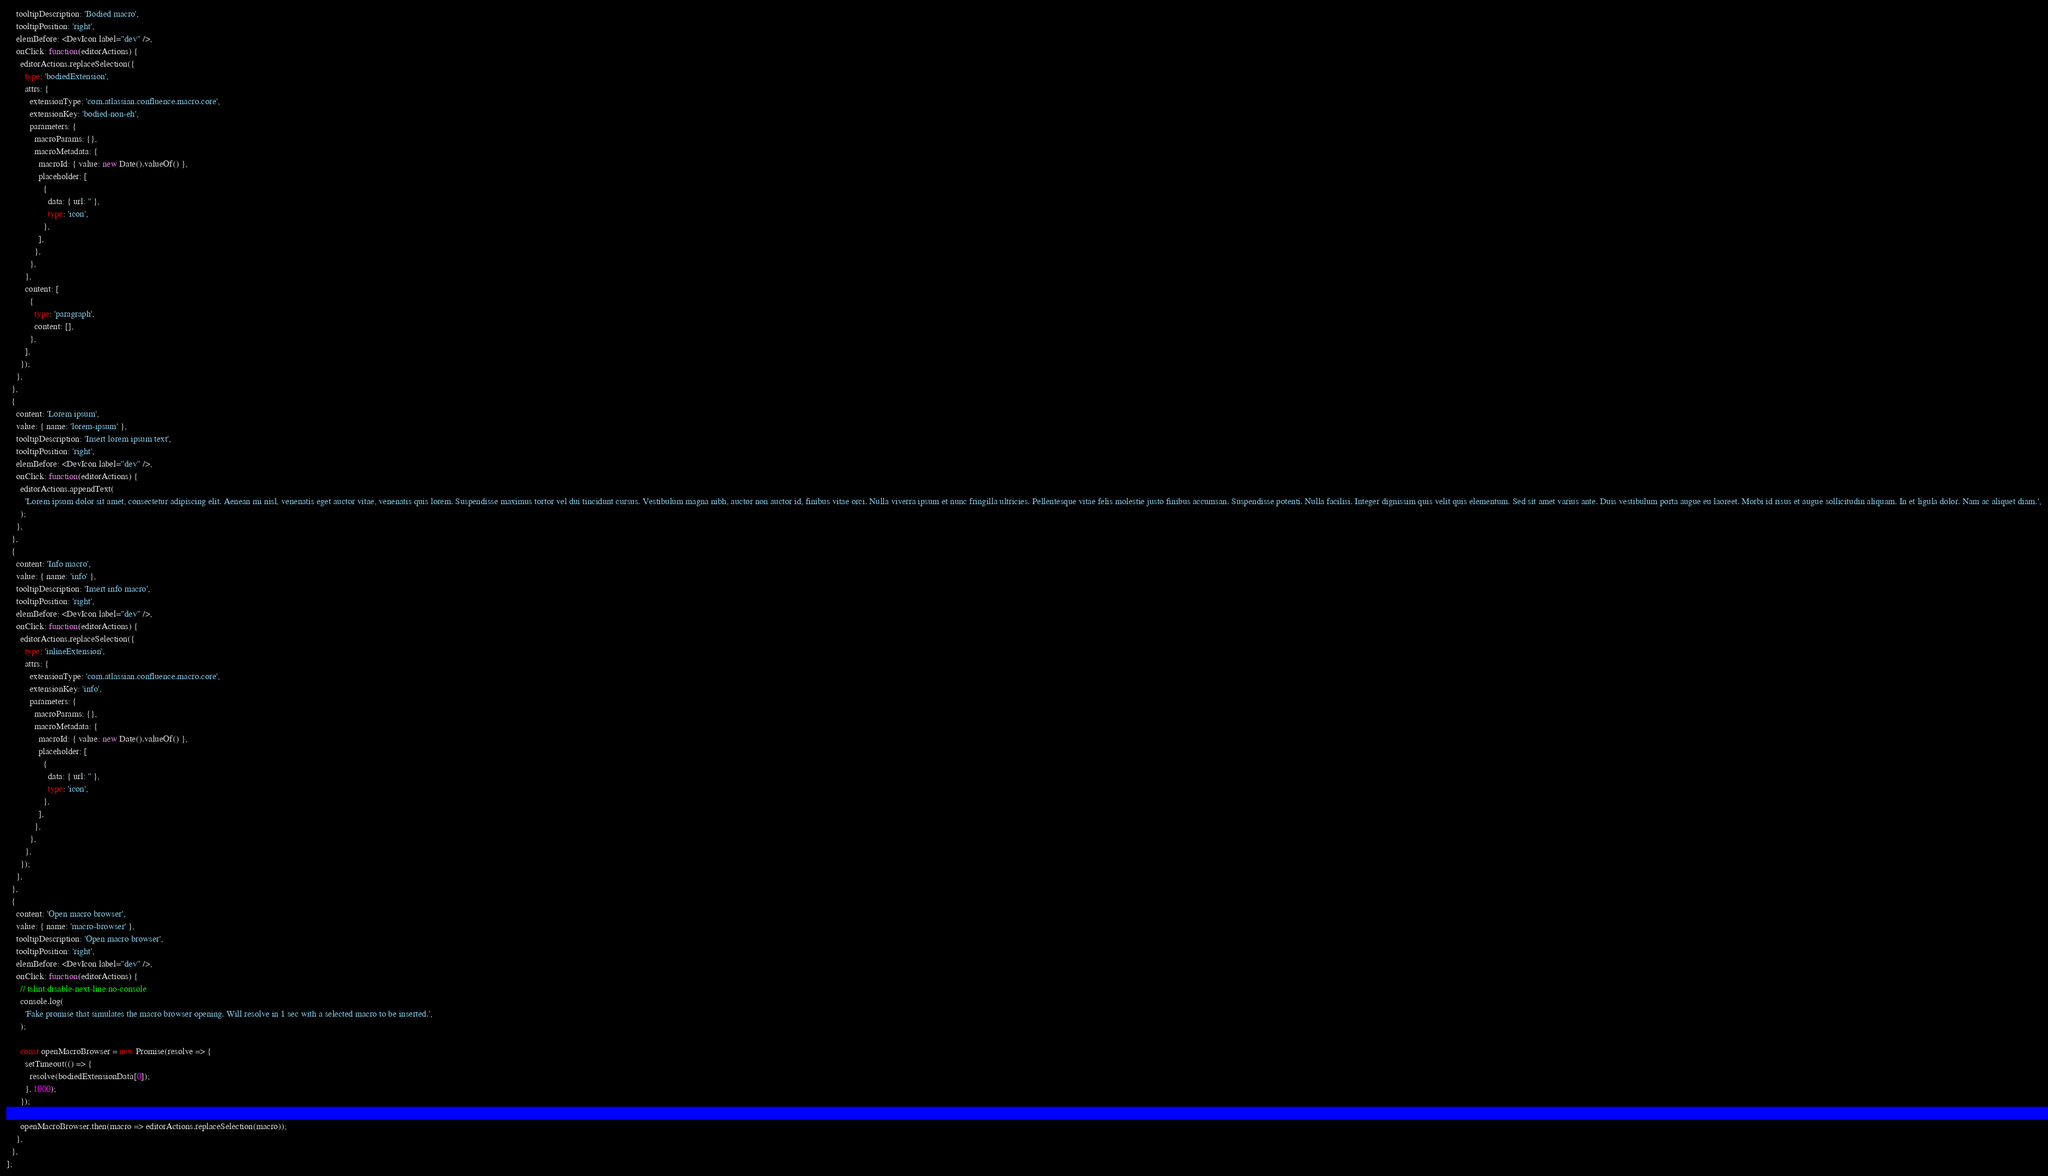<code> <loc_0><loc_0><loc_500><loc_500><_TypeScript_>    tooltipDescription: 'Bodied macro',
    tooltipPosition: 'right',
    elemBefore: <DevIcon label="dev" />,
    onClick: function(editorActions) {
      editorActions.replaceSelection({
        type: 'bodiedExtension',
        attrs: {
          extensionType: 'com.atlassian.confluence.macro.core',
          extensionKey: 'bodied-non-eh',
          parameters: {
            macroParams: {},
            macroMetadata: {
              macroId: { value: new Date().valueOf() },
              placeholder: [
                {
                  data: { url: '' },
                  type: 'icon',
                },
              ],
            },
          },
        },
        content: [
          {
            type: 'paragraph',
            content: [],
          },
        ],
      });
    },
  },
  {
    content: 'Lorem ipsum',
    value: { name: 'lorem-ipsum' },
    tooltipDescription: 'Insert lorem ipsum text',
    tooltipPosition: 'right',
    elemBefore: <DevIcon label="dev" />,
    onClick: function(editorActions) {
      editorActions.appendText(
        'Lorem ipsum dolor sit amet, consectetur adipiscing elit. Aenean mi nisl, venenatis eget auctor vitae, venenatis quis lorem. Suspendisse maximus tortor vel dui tincidunt cursus. Vestibulum magna nibh, auctor non auctor id, finibus vitae orci. Nulla viverra ipsum et nunc fringilla ultricies. Pellentesque vitae felis molestie justo finibus accumsan. Suspendisse potenti. Nulla facilisi. Integer dignissim quis velit quis elementum. Sed sit amet varius ante. Duis vestibulum porta augue eu laoreet. Morbi id risus et augue sollicitudin aliquam. In et ligula dolor. Nam ac aliquet diam.',
      );
    },
  },
  {
    content: 'Info macro',
    value: { name: 'info' },
    tooltipDescription: 'Insert info macro',
    tooltipPosition: 'right',
    elemBefore: <DevIcon label="dev" />,
    onClick: function(editorActions) {
      editorActions.replaceSelection({
        type: 'inlineExtension',
        attrs: {
          extensionType: 'com.atlassian.confluence.macro.core',
          extensionKey: 'info',
          parameters: {
            macroParams: {},
            macroMetadata: {
              macroId: { value: new Date().valueOf() },
              placeholder: [
                {
                  data: { url: '' },
                  type: 'icon',
                },
              ],
            },
          },
        },
      });
    },
  },
  {
    content: 'Open macro browser',
    value: { name: 'macro-browser' },
    tooltipDescription: 'Open macro browser',
    tooltipPosition: 'right',
    elemBefore: <DevIcon label="dev" />,
    onClick: function(editorActions) {
      // tslint:disable-next-line:no-console
      console.log(
        'Fake promise that simulates the macro browser opening. Will resolve in 1 sec with a selected macro to be inserted.',
      );

      const openMacroBrowser = new Promise(resolve => {
        setTimeout(() => {
          resolve(bodiedExtensionData[0]);
        }, 1000);
      });

      openMacroBrowser.then(macro => editorActions.replaceSelection(macro));
    },
  },
];
</code> 